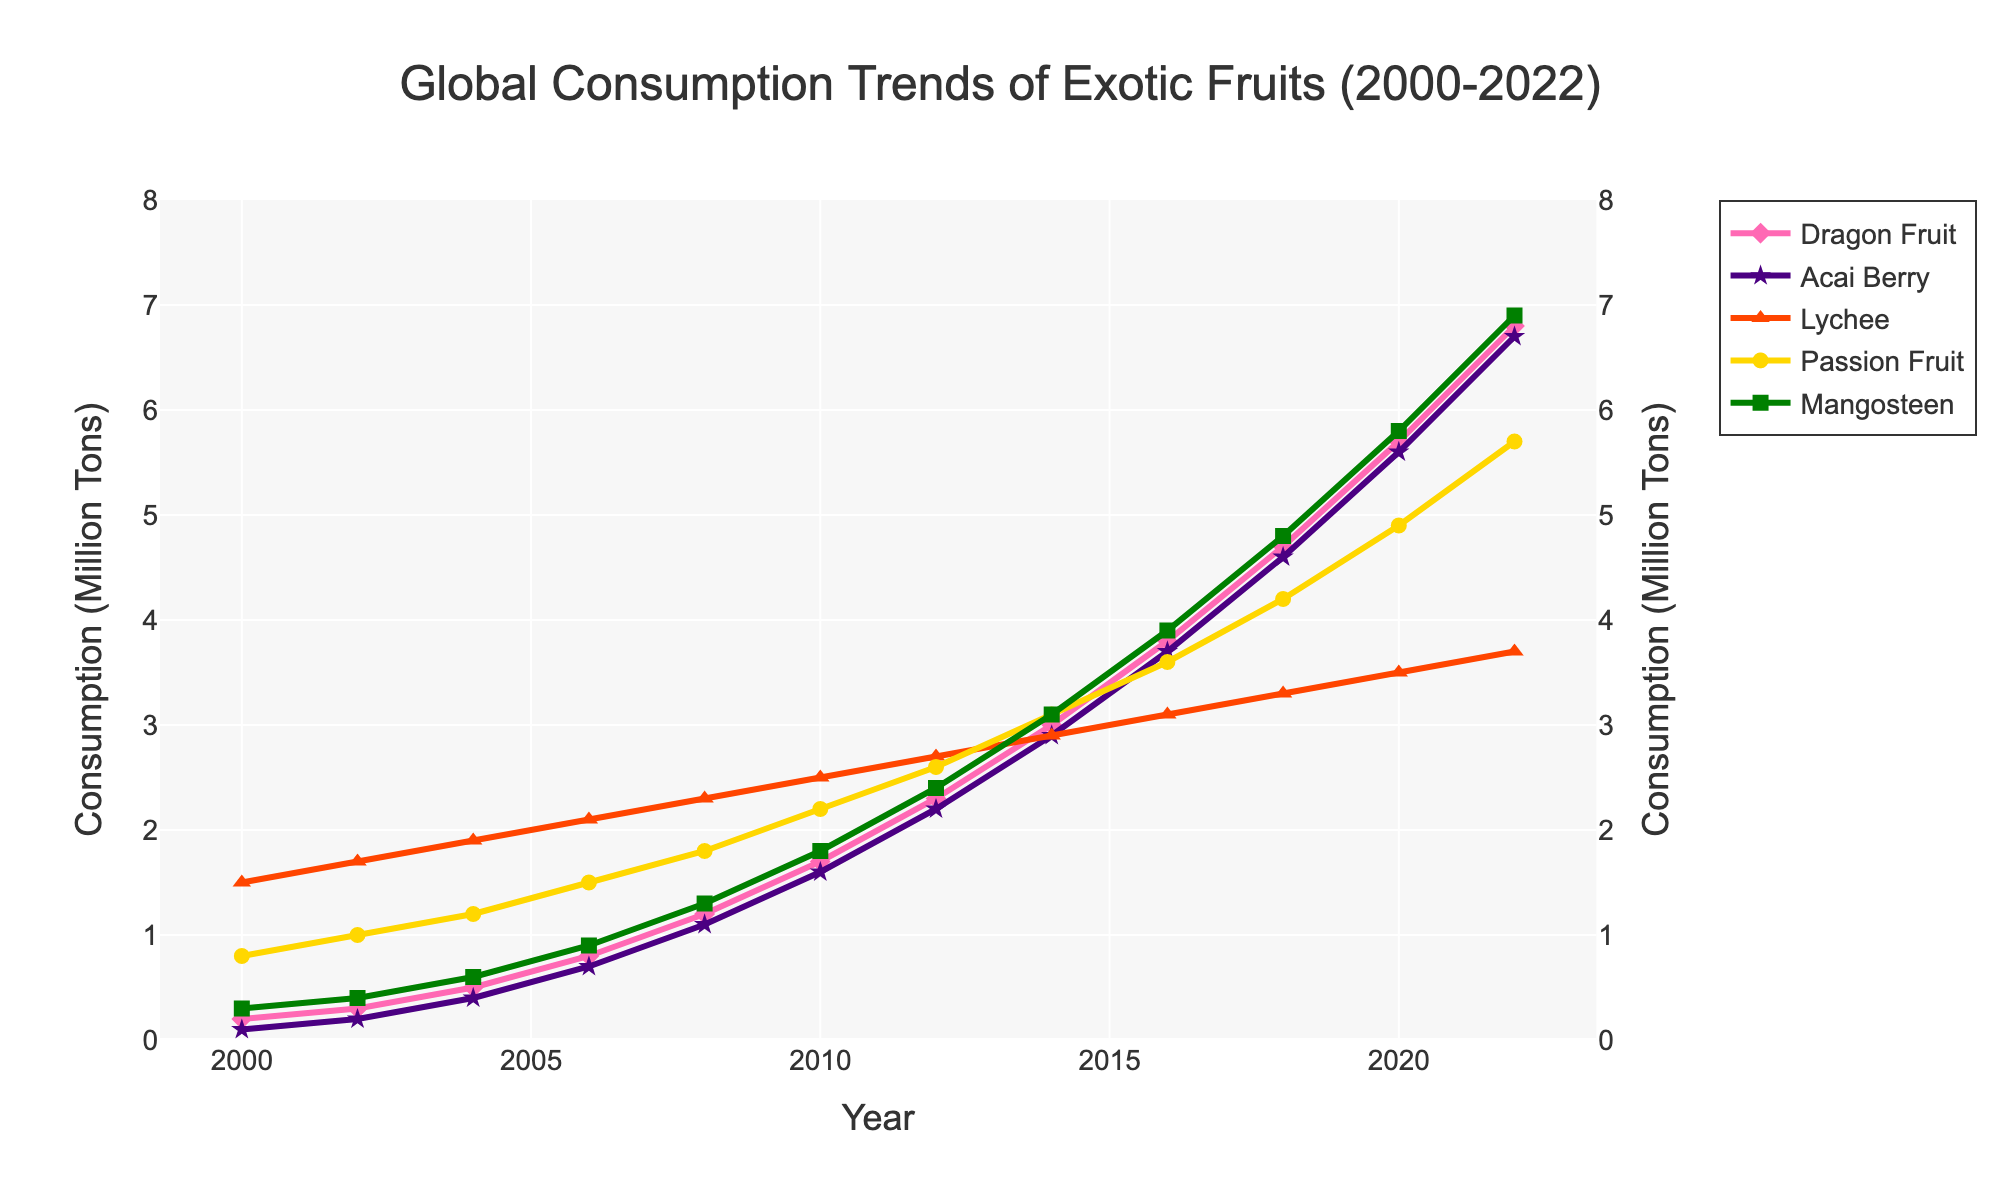What is the overall trend in global consumption of Dragon Fruit from 2000 to 2022? To answer this question, look at the "Dragon Fruit" line on the chart. The data points for Dragon Fruit show a steady increase from 0.2 million tons in 2000 to 6.8 million tons in 2022.
Answer: Steady increase Which year did Acai Berry consumption surpass 4 million tons? Observe the "Acai Berry" line on the chart and note that it crosses the 4 million tons mark between 2016 and 2018. Specifically, in 2018, Acai Berry consumption reaches 4.6 million tons.
Answer: 2018 Compare the consumption of Lychee and Passion Fruit in 2022. Which one is higher? Check the data points for 2022 in the chart. Lychee has a consumption of 3.7 million tons, whereas Passion Fruit has a consumption of 5.7 million tons. Passion Fruit is higher.
Answer: Passion Fruit How much did the consumption of Mangosteen increase from 2008 to 2018? Find the consumption values for Mangosteen in 2008 and 2018 from the data. In 2008, it is 1.3 million tons, and in 2018, it is 4.8 million tons. The increase is 4.8 - 1.3 = 3.5 million tons.
Answer: 3.5 million tons What is the average consumption of Passion Fruit from 2000 to 2022? To find the average, sum all the yearly values of Passion Fruit from 2000 to 2022, then divide by the number of years. (0.8+1.0+1.2+1.5+1.8+2.2+2.6+3.1+3.6+4.2+4.9+5.7)/12 = 2.975 million tons.
Answer: 2.975 million tons In which year did Dragon Fruit consumption equal the consumption of Mangosteen? Examine the line for both Dragon Fruit and Mangosteen. They intersect in 2014 when the consumption of both Dragon Fruit and Mangosteen is 3.0 million tons.
Answer: 2014 Is the rate of increase in global consumption higher for Acai Berry or Lychee between 2006 and 2022? Calculate the consumption increase for both fruits between 2006 and 2022. For Acai Berry: 6.7 - 0.7 = 6.0 million tons. For Lychee: 3.7 - 2.1 = 1.6 million tons. The increase is higher for Acai Berry.
Answer: Acai Berry Which fruit had the smallest increase in consumption from 2000 to 2022? Compare the increase in consumption for all the fruits from 2000 to 2022. Dragon Fruit: 6.8 - 0.2 = 6.6 million tons, Acai Berry: 6.7 - 0.1 = 6.6 million tons, Lychee: 3.7 - 1.5 = 2.2 million tons, Passion Fruit: 5.7 - 0.8 = 4.9 million tons, Mangosteen: 6.9 - 0.3 = 6.6 million tons. Lychee has the smallest increase of 2.2 million tons.
Answer: Lychee 